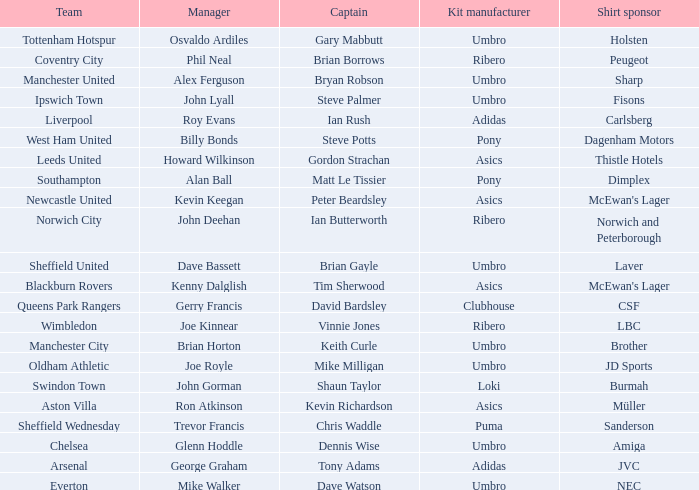Which team has george graham as the manager? Arsenal. 